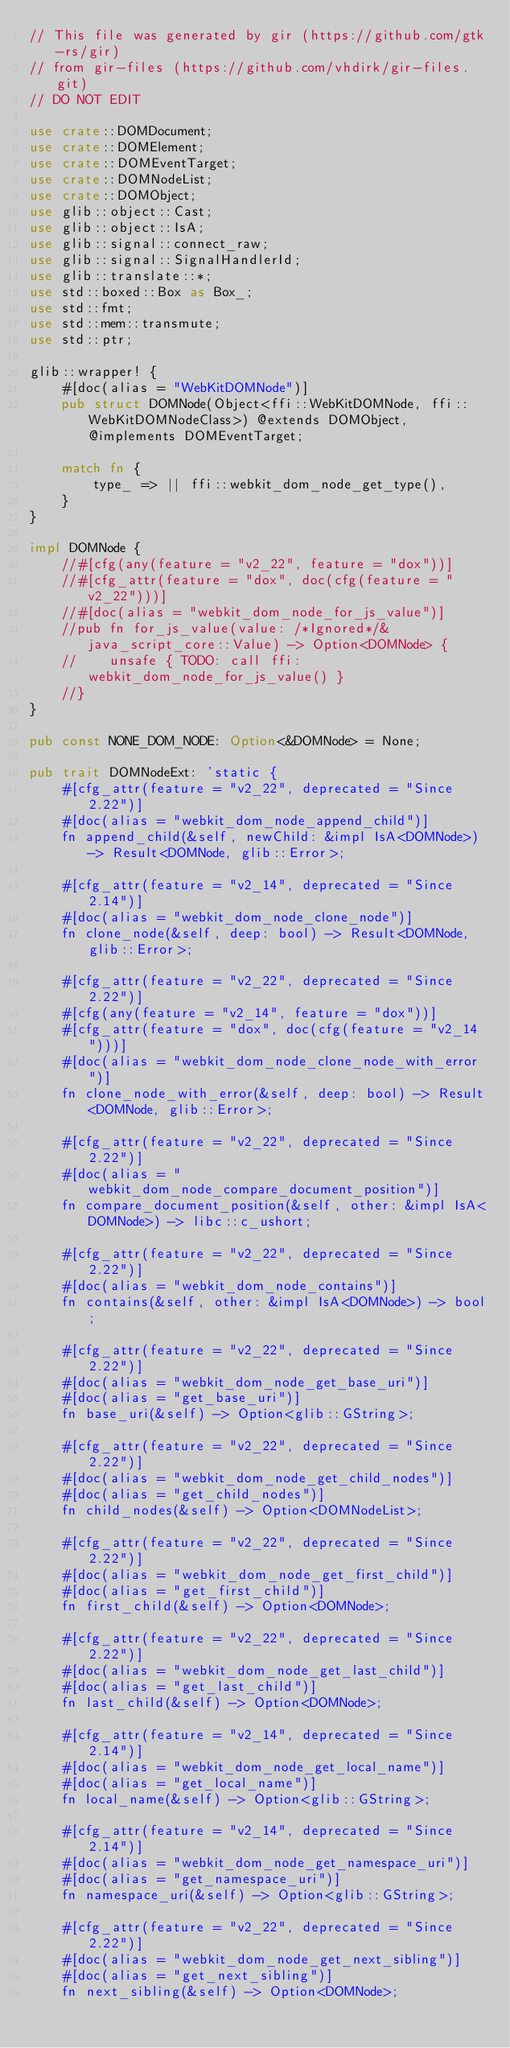Convert code to text. <code><loc_0><loc_0><loc_500><loc_500><_Rust_>// This file was generated by gir (https://github.com/gtk-rs/gir)
// from gir-files (https://github.com/vhdirk/gir-files.git)
// DO NOT EDIT

use crate::DOMDocument;
use crate::DOMElement;
use crate::DOMEventTarget;
use crate::DOMNodeList;
use crate::DOMObject;
use glib::object::Cast;
use glib::object::IsA;
use glib::signal::connect_raw;
use glib::signal::SignalHandlerId;
use glib::translate::*;
use std::boxed::Box as Box_;
use std::fmt;
use std::mem::transmute;
use std::ptr;

glib::wrapper! {
    #[doc(alias = "WebKitDOMNode")]
    pub struct DOMNode(Object<ffi::WebKitDOMNode, ffi::WebKitDOMNodeClass>) @extends DOMObject, @implements DOMEventTarget;

    match fn {
        type_ => || ffi::webkit_dom_node_get_type(),
    }
}

impl DOMNode {
    //#[cfg(any(feature = "v2_22", feature = "dox"))]
    //#[cfg_attr(feature = "dox", doc(cfg(feature = "v2_22")))]
    //#[doc(alias = "webkit_dom_node_for_js_value")]
    //pub fn for_js_value(value: /*Ignored*/&java_script_core::Value) -> Option<DOMNode> {
    //    unsafe { TODO: call ffi:webkit_dom_node_for_js_value() }
    //}
}

pub const NONE_DOM_NODE: Option<&DOMNode> = None;

pub trait DOMNodeExt: 'static {
    #[cfg_attr(feature = "v2_22", deprecated = "Since 2.22")]
    #[doc(alias = "webkit_dom_node_append_child")]
    fn append_child(&self, newChild: &impl IsA<DOMNode>) -> Result<DOMNode, glib::Error>;

    #[cfg_attr(feature = "v2_14", deprecated = "Since 2.14")]
    #[doc(alias = "webkit_dom_node_clone_node")]
    fn clone_node(&self, deep: bool) -> Result<DOMNode, glib::Error>;

    #[cfg_attr(feature = "v2_22", deprecated = "Since 2.22")]
    #[cfg(any(feature = "v2_14", feature = "dox"))]
    #[cfg_attr(feature = "dox", doc(cfg(feature = "v2_14")))]
    #[doc(alias = "webkit_dom_node_clone_node_with_error")]
    fn clone_node_with_error(&self, deep: bool) -> Result<DOMNode, glib::Error>;

    #[cfg_attr(feature = "v2_22", deprecated = "Since 2.22")]
    #[doc(alias = "webkit_dom_node_compare_document_position")]
    fn compare_document_position(&self, other: &impl IsA<DOMNode>) -> libc::c_ushort;

    #[cfg_attr(feature = "v2_22", deprecated = "Since 2.22")]
    #[doc(alias = "webkit_dom_node_contains")]
    fn contains(&self, other: &impl IsA<DOMNode>) -> bool;

    #[cfg_attr(feature = "v2_22", deprecated = "Since 2.22")]
    #[doc(alias = "webkit_dom_node_get_base_uri")]
    #[doc(alias = "get_base_uri")]
    fn base_uri(&self) -> Option<glib::GString>;

    #[cfg_attr(feature = "v2_22", deprecated = "Since 2.22")]
    #[doc(alias = "webkit_dom_node_get_child_nodes")]
    #[doc(alias = "get_child_nodes")]
    fn child_nodes(&self) -> Option<DOMNodeList>;

    #[cfg_attr(feature = "v2_22", deprecated = "Since 2.22")]
    #[doc(alias = "webkit_dom_node_get_first_child")]
    #[doc(alias = "get_first_child")]
    fn first_child(&self) -> Option<DOMNode>;

    #[cfg_attr(feature = "v2_22", deprecated = "Since 2.22")]
    #[doc(alias = "webkit_dom_node_get_last_child")]
    #[doc(alias = "get_last_child")]
    fn last_child(&self) -> Option<DOMNode>;

    #[cfg_attr(feature = "v2_14", deprecated = "Since 2.14")]
    #[doc(alias = "webkit_dom_node_get_local_name")]
    #[doc(alias = "get_local_name")]
    fn local_name(&self) -> Option<glib::GString>;

    #[cfg_attr(feature = "v2_14", deprecated = "Since 2.14")]
    #[doc(alias = "webkit_dom_node_get_namespace_uri")]
    #[doc(alias = "get_namespace_uri")]
    fn namespace_uri(&self) -> Option<glib::GString>;

    #[cfg_attr(feature = "v2_22", deprecated = "Since 2.22")]
    #[doc(alias = "webkit_dom_node_get_next_sibling")]
    #[doc(alias = "get_next_sibling")]
    fn next_sibling(&self) -> Option<DOMNode>;
</code> 